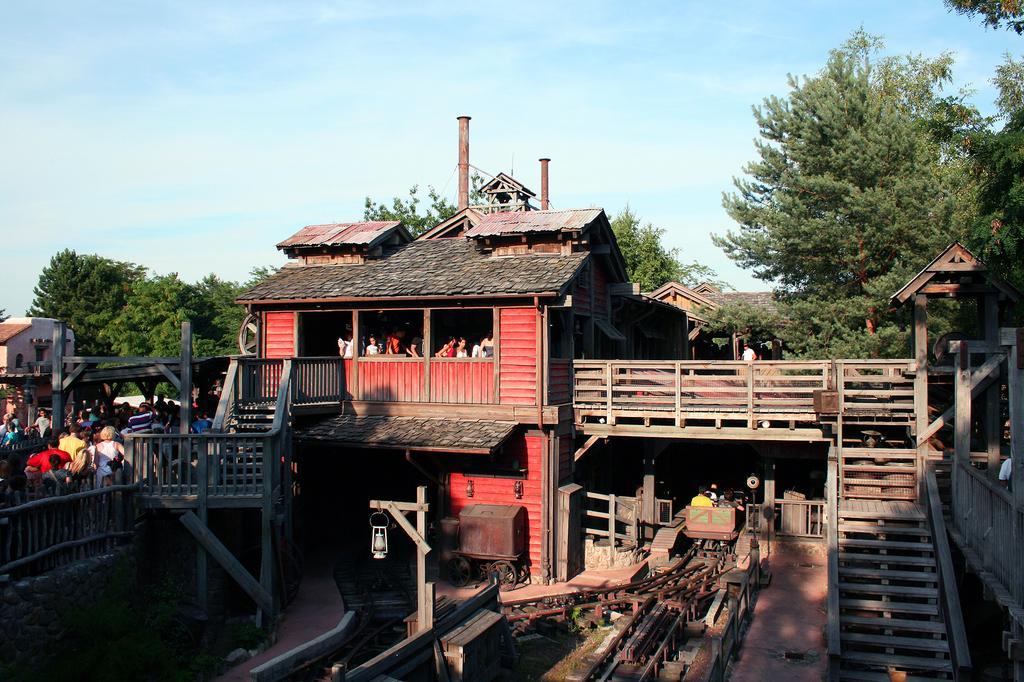Could you give a brief overview of what you see in this image? In this image there is a building. Left side few persons are standing behind the fence. Few persons are inside the building. A lantern is hanging to a pole. Right side there is a staircase. A person is behind the fence. Background there are few trees. Top of the image there is sky. 